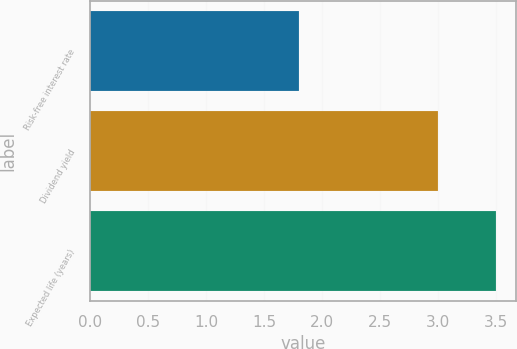<chart> <loc_0><loc_0><loc_500><loc_500><bar_chart><fcel>Risk-free interest rate<fcel>Dividend yield<fcel>Expected life (years)<nl><fcel>1.8<fcel>3<fcel>3.5<nl></chart> 